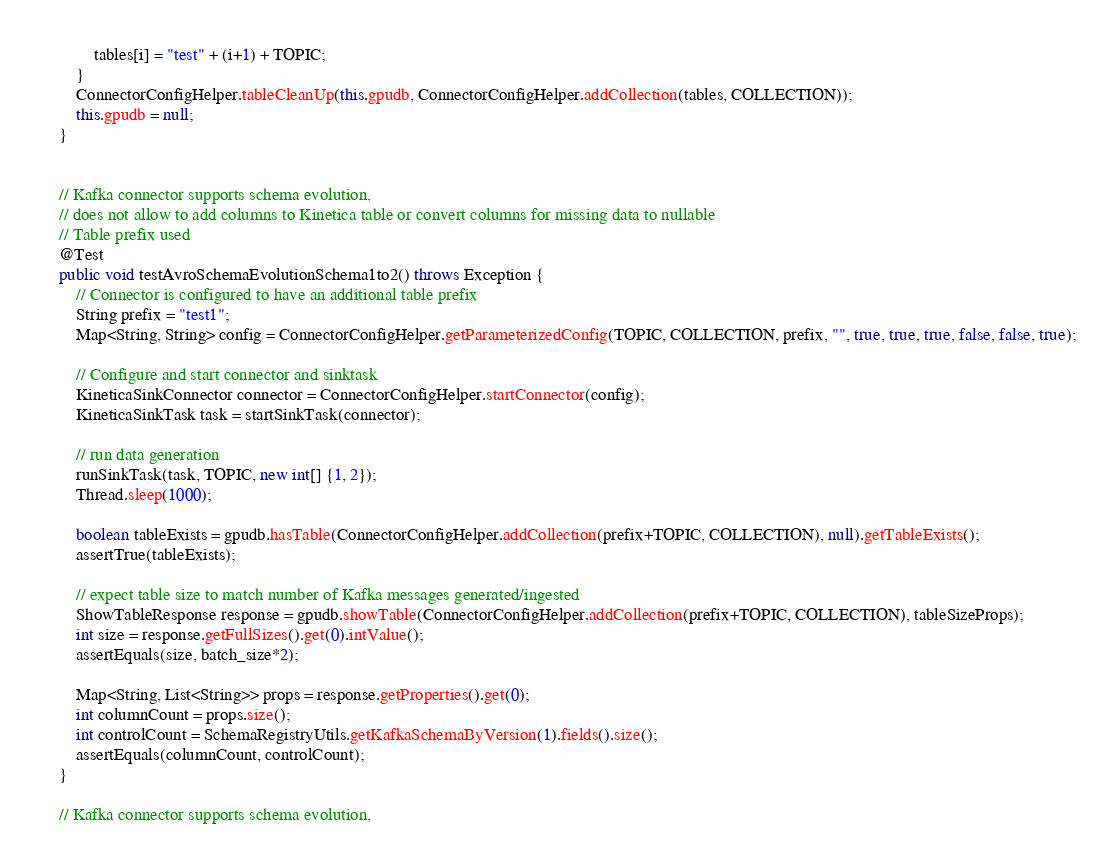<code> <loc_0><loc_0><loc_500><loc_500><_Java_>            tables[i] = "test" + (i+1) + TOPIC;
        }
        ConnectorConfigHelper.tableCleanUp(this.gpudb, ConnectorConfigHelper.addCollection(tables, COLLECTION));
        this.gpudb = null;
    }
    

    // Kafka connector supports schema evolution,  
    // does not allow to add columns to Kinetica table or convert columns for missing data to nullable
    // Table prefix used 
    @Test 
    public void testAvroSchemaEvolutionSchema1to2() throws Exception {
        // Connector is configured to have an additional table prefix
        String prefix = "test1";
        Map<String, String> config = ConnectorConfigHelper.getParameterizedConfig(TOPIC, COLLECTION, prefix, "", true, true, true, false, false, true);

        // Configure and start connector and sinktask
        KineticaSinkConnector connector = ConnectorConfigHelper.startConnector(config);
        KineticaSinkTask task = startSinkTask(connector); 

        // run data generation
        runSinkTask(task, TOPIC, new int[] {1, 2});
        Thread.sleep(1000);
        
        boolean tableExists = gpudb.hasTable(ConnectorConfigHelper.addCollection(prefix+TOPIC, COLLECTION), null).getTableExists(); 
        assertTrue(tableExists);

        // expect table size to match number of Kafka messages generated/ingested
        ShowTableResponse response = gpudb.showTable(ConnectorConfigHelper.addCollection(prefix+TOPIC, COLLECTION), tableSizeProps);        
        int size = response.getFullSizes().get(0).intValue();
        assertEquals(size, batch_size*2);
        
        Map<String, List<String>> props = response.getProperties().get(0);
        int columnCount = props.size();
        int controlCount = SchemaRegistryUtils.getKafkaSchemaByVersion(1).fields().size();
        assertEquals(columnCount, controlCount);
    }

    // Kafka connector supports schema evolution,  </code> 